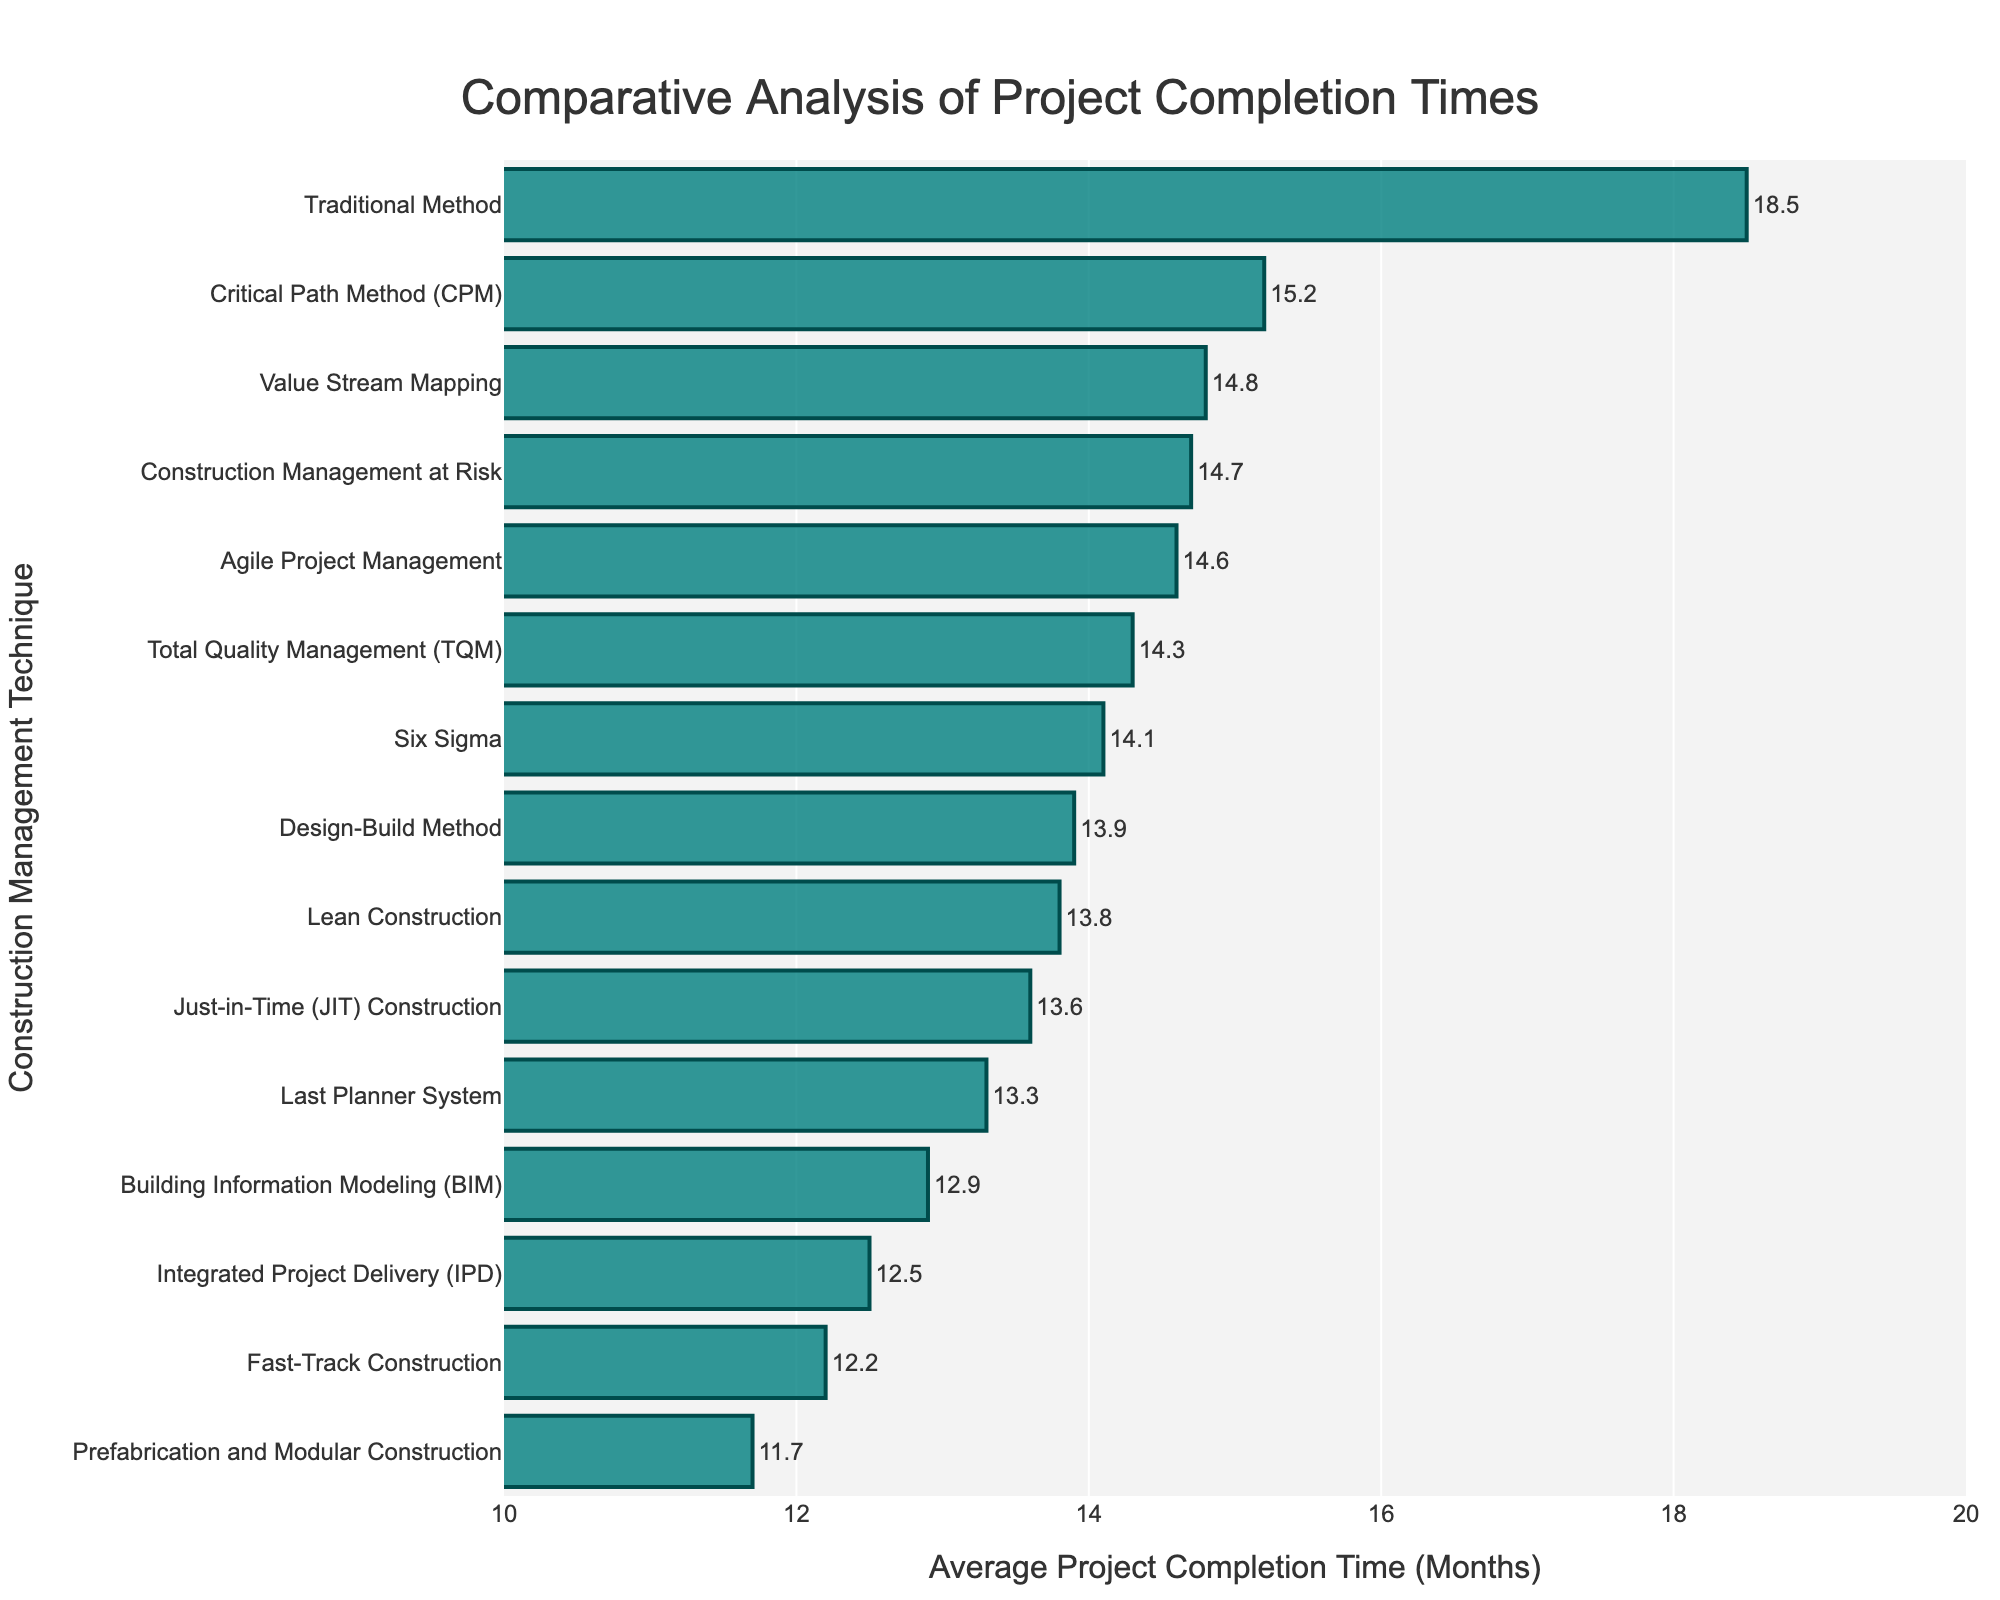Which construction management technique has the shortest average project completion time? Look for the bar representing the smallest value on the x-axis. The shortest bar corresponds to Prefabrication and Modular Construction with a completion time of 11.7 months.
Answer: Prefabrication and Modular Construction Which technique has the longest average project completion time? Identify the bar with the largest value on the x-axis. The longest bar corresponds to the Traditional Method with a completion time of 18.5 months.
Answer: Traditional Method What is the difference in average project completion times between the Critical Path Method (CPM) and Lean Construction? Find the bars for CPM and Lean Construction. CPM has an average of 15.2 months, and Lean Construction has 13.8 months. Subtract Lean Construction's time from CPM's time: 15.2 - 13.8 = 1.4 months.
Answer: 1.4 months How many techniques have an average project completion time of less than 14 months? Count the number of bars with values less than 14 on the x-axis. The techniques are Lean Construction, Agile Project Management, BIM, Last Planner System, IPD, Prefabrication, JIT Construction, and Fast-Track Construction, which total to 8 techniques.
Answer: 8 techniques Which technique has the most similar average project completion time to Six Sigma? Compare the value of Six Sigma, which is 14.1 months, to other techniques' values. The closest is TQM with 14.3 months, a difference of just 0.2 months.
Answer: TQM (Total Quality Management) What is the average project completion time for all techniques combined? Add all the project completion times and divide by the number of techniques. The sum is 223.7 months for 15 techniques, so the average is 223.7 / 15 ≈ 14.9 months.
Answer: 14.9 months How does the average completion time of Fast-Track Construction compare to that of the Traditional Method? Fast-Track Construction has a completion time of 12.2 months, and the Traditional Method is 18.5 months. Subtract Fast-Track's time from Traditional: 18.5 - 12.2 = 6.3 months.
Answer: 6.3 months faster What is the median average project completion time? Order the techniques by completion time and find the middle value. The middle value (8th technique) is BIM with 12.9 months.
Answer: 12.9 months Which techniques have an average project completion time between 13.5 and 14.5 months? Identify bars intersecting the range 13.5 to 14.5 months. These are Agile Project Management, Six Sigma, JIT Construction, TQM, and Design-Build Method.
Answer: 5 Techniques 